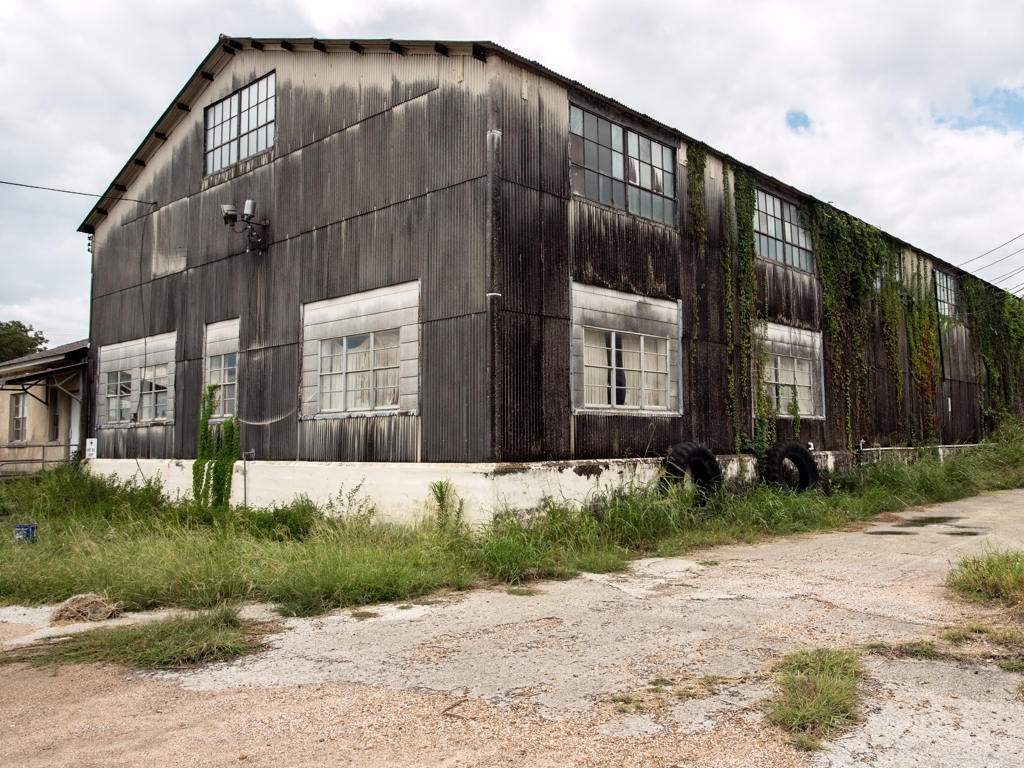What is the overall quality of the image? The image appears to be of average quality. It has good lighting and the details are visible, but it seems there may be some slight graininess when viewed at full size. The focus and composition are decent, capturing the rustic charm of the abandoned industrial building, yet might not be considered high-definition by current standards. 